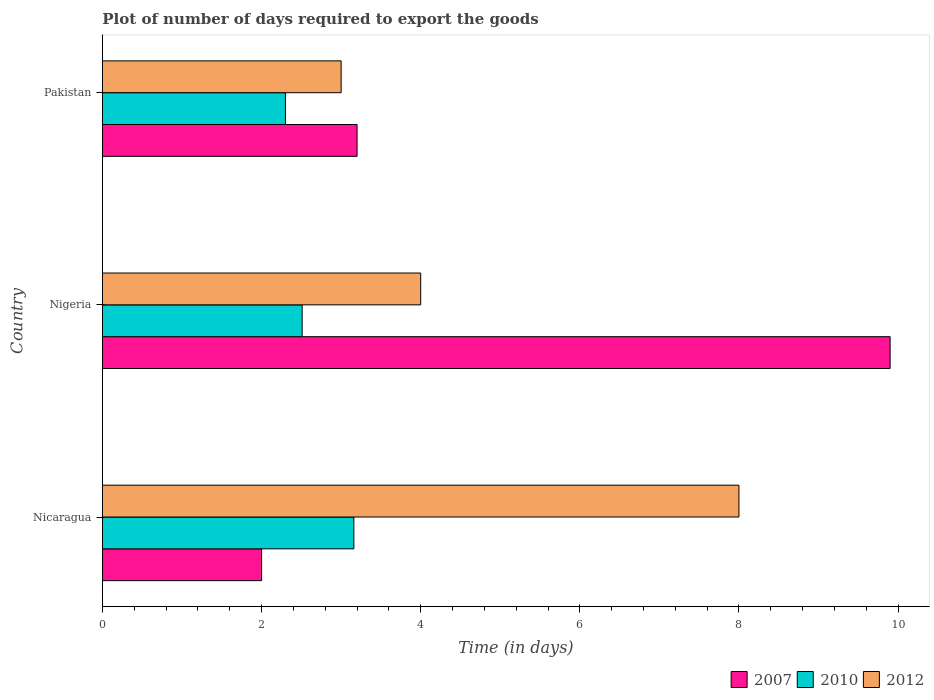Are the number of bars on each tick of the Y-axis equal?
Provide a short and direct response. Yes. What is the label of the 2nd group of bars from the top?
Offer a terse response. Nigeria. In how many cases, is the number of bars for a given country not equal to the number of legend labels?
Offer a very short reply. 0. What is the time required to export goods in 2007 in Nicaragua?
Keep it short and to the point. 2. Across all countries, what is the maximum time required to export goods in 2012?
Offer a terse response. 8. Across all countries, what is the minimum time required to export goods in 2007?
Offer a very short reply. 2. In which country was the time required to export goods in 2007 maximum?
Keep it short and to the point. Nigeria. What is the total time required to export goods in 2012 in the graph?
Offer a terse response. 15. What is the difference between the time required to export goods in 2007 in Nicaragua and that in Nigeria?
Your answer should be compact. -7.9. What is the difference between the time required to export goods in 2007 in Nicaragua and the time required to export goods in 2010 in Nigeria?
Provide a succinct answer. -0.51. What is the average time required to export goods in 2007 per country?
Give a very brief answer. 5.03. What is the difference between the time required to export goods in 2010 and time required to export goods in 2007 in Nicaragua?
Keep it short and to the point. 1.16. In how many countries, is the time required to export goods in 2012 greater than 9.2 days?
Your answer should be very brief. 0. What is the ratio of the time required to export goods in 2007 in Nicaragua to that in Pakistan?
Keep it short and to the point. 0.62. What is the difference between the highest and the lowest time required to export goods in 2010?
Offer a very short reply. 0.86. In how many countries, is the time required to export goods in 2007 greater than the average time required to export goods in 2007 taken over all countries?
Ensure brevity in your answer.  1. What does the 2nd bar from the bottom in Nicaragua represents?
Your response must be concise. 2010. Is it the case that in every country, the sum of the time required to export goods in 2012 and time required to export goods in 2007 is greater than the time required to export goods in 2010?
Your answer should be compact. Yes. How many bars are there?
Keep it short and to the point. 9. How many countries are there in the graph?
Make the answer very short. 3. What is the difference between two consecutive major ticks on the X-axis?
Keep it short and to the point. 2. Are the values on the major ticks of X-axis written in scientific E-notation?
Provide a succinct answer. No. Does the graph contain grids?
Keep it short and to the point. No. Where does the legend appear in the graph?
Provide a succinct answer. Bottom right. How many legend labels are there?
Provide a succinct answer. 3. How are the legend labels stacked?
Your response must be concise. Horizontal. What is the title of the graph?
Your answer should be compact. Plot of number of days required to export the goods. What is the label or title of the X-axis?
Provide a succinct answer. Time (in days). What is the label or title of the Y-axis?
Provide a succinct answer. Country. What is the Time (in days) of 2010 in Nicaragua?
Offer a terse response. 3.16. What is the Time (in days) of 2010 in Nigeria?
Provide a short and direct response. 2.51. What is the Time (in days) of 2012 in Nigeria?
Your answer should be very brief. 4. What is the Time (in days) in 2007 in Pakistan?
Give a very brief answer. 3.2. What is the Time (in days) of 2010 in Pakistan?
Your answer should be very brief. 2.3. Across all countries, what is the maximum Time (in days) of 2007?
Offer a terse response. 9.9. Across all countries, what is the maximum Time (in days) in 2010?
Keep it short and to the point. 3.16. Across all countries, what is the minimum Time (in days) of 2010?
Your response must be concise. 2.3. Across all countries, what is the minimum Time (in days) of 2012?
Ensure brevity in your answer.  3. What is the total Time (in days) of 2007 in the graph?
Your answer should be compact. 15.1. What is the total Time (in days) in 2010 in the graph?
Make the answer very short. 7.97. What is the total Time (in days) of 2012 in the graph?
Keep it short and to the point. 15. What is the difference between the Time (in days) in 2010 in Nicaragua and that in Nigeria?
Your answer should be very brief. 0.65. What is the difference between the Time (in days) of 2012 in Nicaragua and that in Nigeria?
Ensure brevity in your answer.  4. What is the difference between the Time (in days) of 2007 in Nicaragua and that in Pakistan?
Ensure brevity in your answer.  -1.2. What is the difference between the Time (in days) of 2010 in Nicaragua and that in Pakistan?
Offer a very short reply. 0.86. What is the difference between the Time (in days) in 2007 in Nigeria and that in Pakistan?
Ensure brevity in your answer.  6.7. What is the difference between the Time (in days) of 2010 in Nigeria and that in Pakistan?
Make the answer very short. 0.21. What is the difference between the Time (in days) of 2007 in Nicaragua and the Time (in days) of 2010 in Nigeria?
Offer a terse response. -0.51. What is the difference between the Time (in days) of 2010 in Nicaragua and the Time (in days) of 2012 in Nigeria?
Provide a short and direct response. -0.84. What is the difference between the Time (in days) of 2007 in Nicaragua and the Time (in days) of 2010 in Pakistan?
Provide a succinct answer. -0.3. What is the difference between the Time (in days) of 2007 in Nicaragua and the Time (in days) of 2012 in Pakistan?
Your answer should be very brief. -1. What is the difference between the Time (in days) of 2010 in Nicaragua and the Time (in days) of 2012 in Pakistan?
Offer a terse response. 0.16. What is the difference between the Time (in days) of 2007 in Nigeria and the Time (in days) of 2010 in Pakistan?
Provide a succinct answer. 7.6. What is the difference between the Time (in days) of 2007 in Nigeria and the Time (in days) of 2012 in Pakistan?
Offer a very short reply. 6.9. What is the difference between the Time (in days) in 2010 in Nigeria and the Time (in days) in 2012 in Pakistan?
Offer a very short reply. -0.49. What is the average Time (in days) of 2007 per country?
Keep it short and to the point. 5.03. What is the average Time (in days) of 2010 per country?
Offer a terse response. 2.66. What is the average Time (in days) in 2012 per country?
Offer a terse response. 5. What is the difference between the Time (in days) of 2007 and Time (in days) of 2010 in Nicaragua?
Keep it short and to the point. -1.16. What is the difference between the Time (in days) of 2007 and Time (in days) of 2012 in Nicaragua?
Your answer should be compact. -6. What is the difference between the Time (in days) in 2010 and Time (in days) in 2012 in Nicaragua?
Keep it short and to the point. -4.84. What is the difference between the Time (in days) in 2007 and Time (in days) in 2010 in Nigeria?
Offer a terse response. 7.39. What is the difference between the Time (in days) in 2010 and Time (in days) in 2012 in Nigeria?
Keep it short and to the point. -1.49. What is the difference between the Time (in days) of 2010 and Time (in days) of 2012 in Pakistan?
Provide a succinct answer. -0.7. What is the ratio of the Time (in days) of 2007 in Nicaragua to that in Nigeria?
Give a very brief answer. 0.2. What is the ratio of the Time (in days) in 2010 in Nicaragua to that in Nigeria?
Your answer should be very brief. 1.26. What is the ratio of the Time (in days) of 2010 in Nicaragua to that in Pakistan?
Your answer should be very brief. 1.37. What is the ratio of the Time (in days) in 2012 in Nicaragua to that in Pakistan?
Your response must be concise. 2.67. What is the ratio of the Time (in days) of 2007 in Nigeria to that in Pakistan?
Provide a short and direct response. 3.09. What is the ratio of the Time (in days) in 2010 in Nigeria to that in Pakistan?
Offer a very short reply. 1.09. What is the ratio of the Time (in days) in 2012 in Nigeria to that in Pakistan?
Your answer should be compact. 1.33. What is the difference between the highest and the second highest Time (in days) in 2010?
Ensure brevity in your answer.  0.65. What is the difference between the highest and the lowest Time (in days) in 2007?
Offer a terse response. 7.9. What is the difference between the highest and the lowest Time (in days) in 2010?
Make the answer very short. 0.86. 